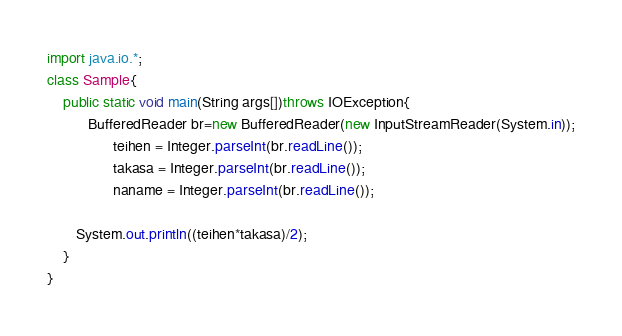Convert code to text. <code><loc_0><loc_0><loc_500><loc_500><_Java_>import java.io.*;
class Sample{
    public static void main(String args[])throws IOException{
    	  BufferedReader br=new BufferedReader(new InputStreamReader(System.in));
      			teihen = Integer.parseInt(br.readLine());
     			takasa = Integer.parseInt(br.readLine());
      			naname = Integer.parseInt(br.readLine());
      
       System.out.println((teihen*takasa)/2);
    }
}
</code> 